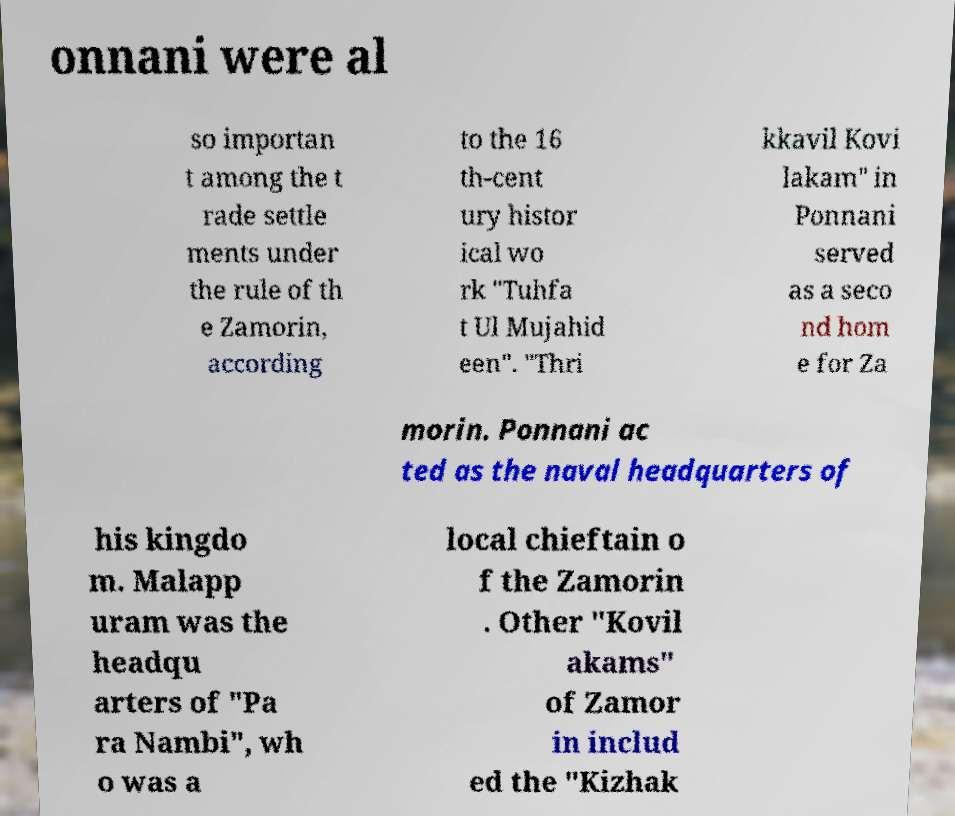Can you accurately transcribe the text from the provided image for me? onnani were al so importan t among the t rade settle ments under the rule of th e Zamorin, according to the 16 th-cent ury histor ical wo rk "Tuhfa t Ul Mujahid een". "Thri kkavil Kovi lakam" in Ponnani served as a seco nd hom e for Za morin. Ponnani ac ted as the naval headquarters of his kingdo m. Malapp uram was the headqu arters of "Pa ra Nambi", wh o was a local chieftain o f the Zamorin . Other "Kovil akams" of Zamor in includ ed the "Kizhak 